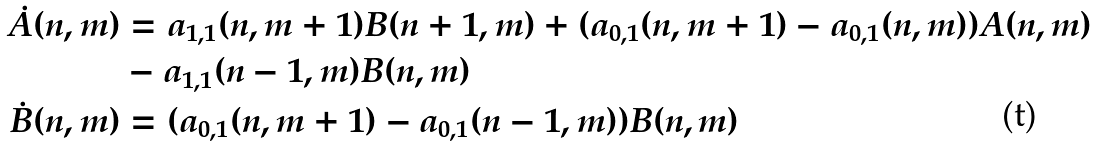Convert formula to latex. <formula><loc_0><loc_0><loc_500><loc_500>\dot { A } ( n , m ) & = a _ { 1 , 1 } ( n , m + 1 ) B ( n + 1 , m ) + ( a _ { 0 , 1 } ( n , m + 1 ) - a _ { 0 , 1 } ( n , m ) ) A ( n , m ) \\ & - a _ { 1 , 1 } ( n - 1 , m ) B ( n , m ) \\ \dot { B } ( n , m ) & = ( a _ { 0 , 1 } ( n , m + 1 ) - a _ { 0 , 1 } ( n - 1 , m ) ) B ( n , m ) \\</formula> 